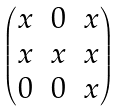Convert formula to latex. <formula><loc_0><loc_0><loc_500><loc_500>\begin{pmatrix} x & 0 & x \\ x & x & x \\ 0 & 0 & x \\ \end{pmatrix}</formula> 